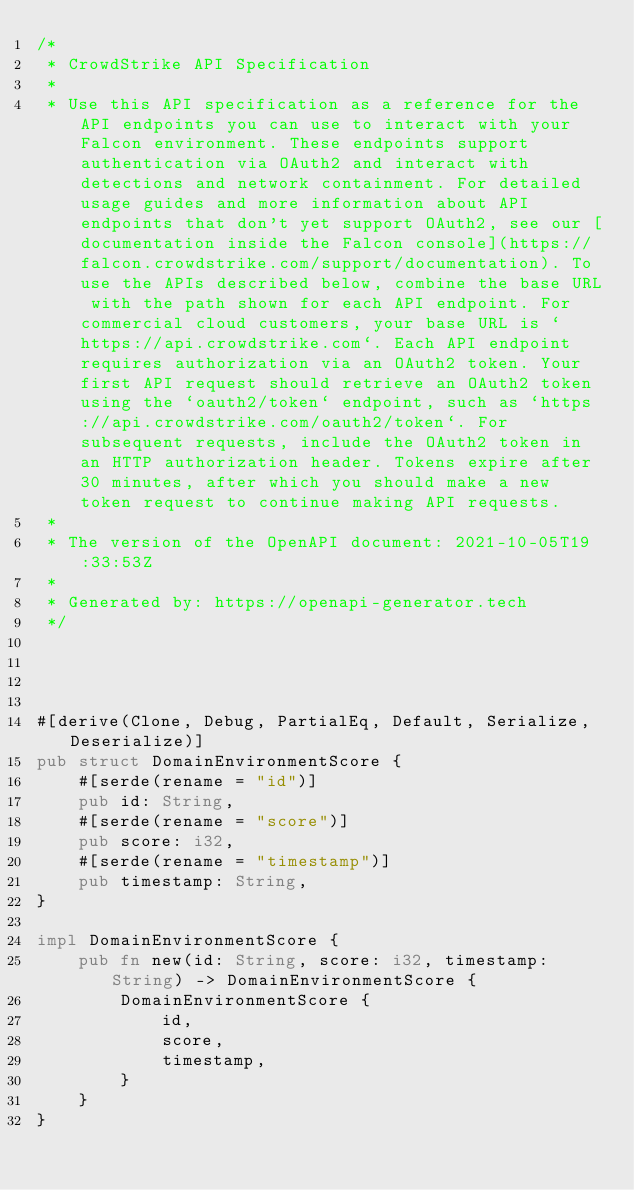<code> <loc_0><loc_0><loc_500><loc_500><_Rust_>/*
 * CrowdStrike API Specification
 *
 * Use this API specification as a reference for the API endpoints you can use to interact with your Falcon environment. These endpoints support authentication via OAuth2 and interact with detections and network containment. For detailed usage guides and more information about API endpoints that don't yet support OAuth2, see our [documentation inside the Falcon console](https://falcon.crowdstrike.com/support/documentation). To use the APIs described below, combine the base URL with the path shown for each API endpoint. For commercial cloud customers, your base URL is `https://api.crowdstrike.com`. Each API endpoint requires authorization via an OAuth2 token. Your first API request should retrieve an OAuth2 token using the `oauth2/token` endpoint, such as `https://api.crowdstrike.com/oauth2/token`. For subsequent requests, include the OAuth2 token in an HTTP authorization header. Tokens expire after 30 minutes, after which you should make a new token request to continue making API requests.
 *
 * The version of the OpenAPI document: 2021-10-05T19:33:53Z
 * 
 * Generated by: https://openapi-generator.tech
 */




#[derive(Clone, Debug, PartialEq, Default, Serialize, Deserialize)]
pub struct DomainEnvironmentScore {
    #[serde(rename = "id")]
    pub id: String,
    #[serde(rename = "score")]
    pub score: i32,
    #[serde(rename = "timestamp")]
    pub timestamp: String,
}

impl DomainEnvironmentScore {
    pub fn new(id: String, score: i32, timestamp: String) -> DomainEnvironmentScore {
        DomainEnvironmentScore {
            id,
            score,
            timestamp,
        }
    }
}


</code> 